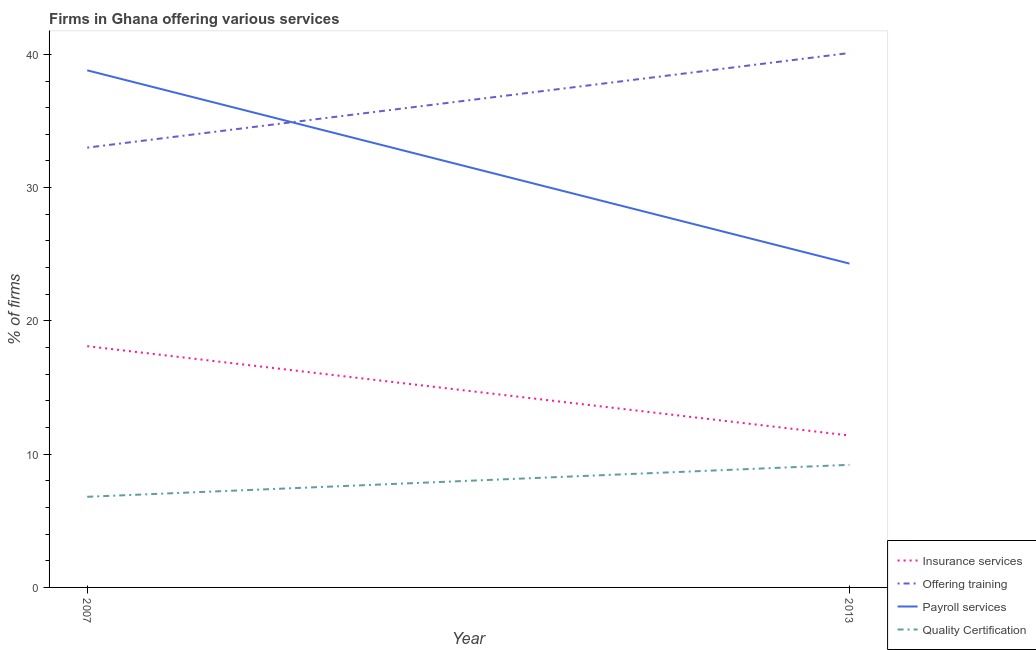Across all years, what is the minimum percentage of firms offering payroll services?
Offer a terse response. 24.3. In which year was the percentage of firms offering payroll services maximum?
Ensure brevity in your answer.  2007. What is the total percentage of firms offering quality certification in the graph?
Your answer should be very brief. 16. What is the difference between the percentage of firms offering insurance services in 2007 and that in 2013?
Your answer should be very brief. 6.7. What is the difference between the percentage of firms offering training in 2007 and the percentage of firms offering insurance services in 2013?
Offer a very short reply. 21.6. What is the average percentage of firms offering training per year?
Offer a terse response. 36.55. In the year 2013, what is the difference between the percentage of firms offering insurance services and percentage of firms offering training?
Offer a very short reply. -28.7. What is the ratio of the percentage of firms offering insurance services in 2007 to that in 2013?
Your answer should be compact. 1.59. Is it the case that in every year, the sum of the percentage of firms offering quality certification and percentage of firms offering training is greater than the sum of percentage of firms offering payroll services and percentage of firms offering insurance services?
Keep it short and to the point. Yes. Is the percentage of firms offering insurance services strictly greater than the percentage of firms offering payroll services over the years?
Offer a very short reply. No. Is the percentage of firms offering insurance services strictly less than the percentage of firms offering quality certification over the years?
Ensure brevity in your answer.  No. How many lines are there?
Provide a short and direct response. 4. How many years are there in the graph?
Make the answer very short. 2. Are the values on the major ticks of Y-axis written in scientific E-notation?
Provide a succinct answer. No. Does the graph contain any zero values?
Your response must be concise. No. How many legend labels are there?
Provide a short and direct response. 4. How are the legend labels stacked?
Offer a very short reply. Vertical. What is the title of the graph?
Your response must be concise. Firms in Ghana offering various services . What is the label or title of the Y-axis?
Ensure brevity in your answer.  % of firms. What is the % of firms in Insurance services in 2007?
Provide a short and direct response. 18.1. What is the % of firms in Offering training in 2007?
Your answer should be very brief. 33. What is the % of firms of Payroll services in 2007?
Ensure brevity in your answer.  38.8. What is the % of firms of Quality Certification in 2007?
Give a very brief answer. 6.8. What is the % of firms in Offering training in 2013?
Give a very brief answer. 40.1. What is the % of firms in Payroll services in 2013?
Provide a short and direct response. 24.3. Across all years, what is the maximum % of firms in Offering training?
Ensure brevity in your answer.  40.1. Across all years, what is the maximum % of firms in Payroll services?
Your answer should be very brief. 38.8. Across all years, what is the maximum % of firms of Quality Certification?
Give a very brief answer. 9.2. Across all years, what is the minimum % of firms in Offering training?
Offer a very short reply. 33. Across all years, what is the minimum % of firms of Payroll services?
Your answer should be compact. 24.3. Across all years, what is the minimum % of firms of Quality Certification?
Ensure brevity in your answer.  6.8. What is the total % of firms of Insurance services in the graph?
Your response must be concise. 29.5. What is the total % of firms of Offering training in the graph?
Your answer should be compact. 73.1. What is the total % of firms of Payroll services in the graph?
Offer a terse response. 63.1. What is the difference between the % of firms in Offering training in 2007 and that in 2013?
Give a very brief answer. -7.1. What is the difference between the % of firms of Quality Certification in 2007 and that in 2013?
Keep it short and to the point. -2.4. What is the difference between the % of firms of Insurance services in 2007 and the % of firms of Payroll services in 2013?
Your response must be concise. -6.2. What is the difference between the % of firms in Insurance services in 2007 and the % of firms in Quality Certification in 2013?
Offer a terse response. 8.9. What is the difference between the % of firms of Offering training in 2007 and the % of firms of Quality Certification in 2013?
Ensure brevity in your answer.  23.8. What is the difference between the % of firms of Payroll services in 2007 and the % of firms of Quality Certification in 2013?
Provide a short and direct response. 29.6. What is the average % of firms in Insurance services per year?
Keep it short and to the point. 14.75. What is the average % of firms in Offering training per year?
Make the answer very short. 36.55. What is the average % of firms of Payroll services per year?
Make the answer very short. 31.55. In the year 2007, what is the difference between the % of firms in Insurance services and % of firms in Offering training?
Your answer should be very brief. -14.9. In the year 2007, what is the difference between the % of firms of Insurance services and % of firms of Payroll services?
Ensure brevity in your answer.  -20.7. In the year 2007, what is the difference between the % of firms of Offering training and % of firms of Quality Certification?
Keep it short and to the point. 26.2. In the year 2007, what is the difference between the % of firms of Payroll services and % of firms of Quality Certification?
Ensure brevity in your answer.  32. In the year 2013, what is the difference between the % of firms in Insurance services and % of firms in Offering training?
Keep it short and to the point. -28.7. In the year 2013, what is the difference between the % of firms of Insurance services and % of firms of Quality Certification?
Offer a very short reply. 2.2. In the year 2013, what is the difference between the % of firms in Offering training and % of firms in Payroll services?
Your answer should be very brief. 15.8. In the year 2013, what is the difference between the % of firms in Offering training and % of firms in Quality Certification?
Make the answer very short. 30.9. What is the ratio of the % of firms in Insurance services in 2007 to that in 2013?
Give a very brief answer. 1.59. What is the ratio of the % of firms in Offering training in 2007 to that in 2013?
Make the answer very short. 0.82. What is the ratio of the % of firms in Payroll services in 2007 to that in 2013?
Make the answer very short. 1.6. What is the ratio of the % of firms in Quality Certification in 2007 to that in 2013?
Provide a short and direct response. 0.74. What is the difference between the highest and the second highest % of firms of Offering training?
Offer a very short reply. 7.1. What is the difference between the highest and the second highest % of firms of Payroll services?
Your response must be concise. 14.5. What is the difference between the highest and the second highest % of firms in Quality Certification?
Your answer should be compact. 2.4. What is the difference between the highest and the lowest % of firms of Offering training?
Make the answer very short. 7.1. What is the difference between the highest and the lowest % of firms in Payroll services?
Your response must be concise. 14.5. What is the difference between the highest and the lowest % of firms of Quality Certification?
Provide a short and direct response. 2.4. 